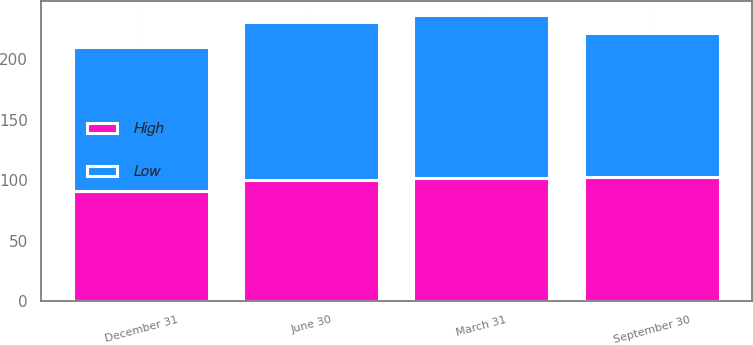Convert chart. <chart><loc_0><loc_0><loc_500><loc_500><stacked_bar_chart><ecel><fcel>March 31<fcel>June 30<fcel>September 30<fcel>December 31<nl><fcel>High<fcel>101.65<fcel>100.3<fcel>102.36<fcel>91.54<nl><fcel>Low<fcel>135<fcel>130.17<fcel>119.16<fcel>118.72<nl></chart> 